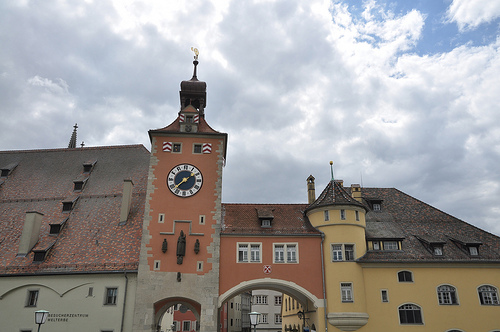Please provide a short description for this region: [0.96, 0.73, 0.99, 0.78]. This region is another window on the building. 